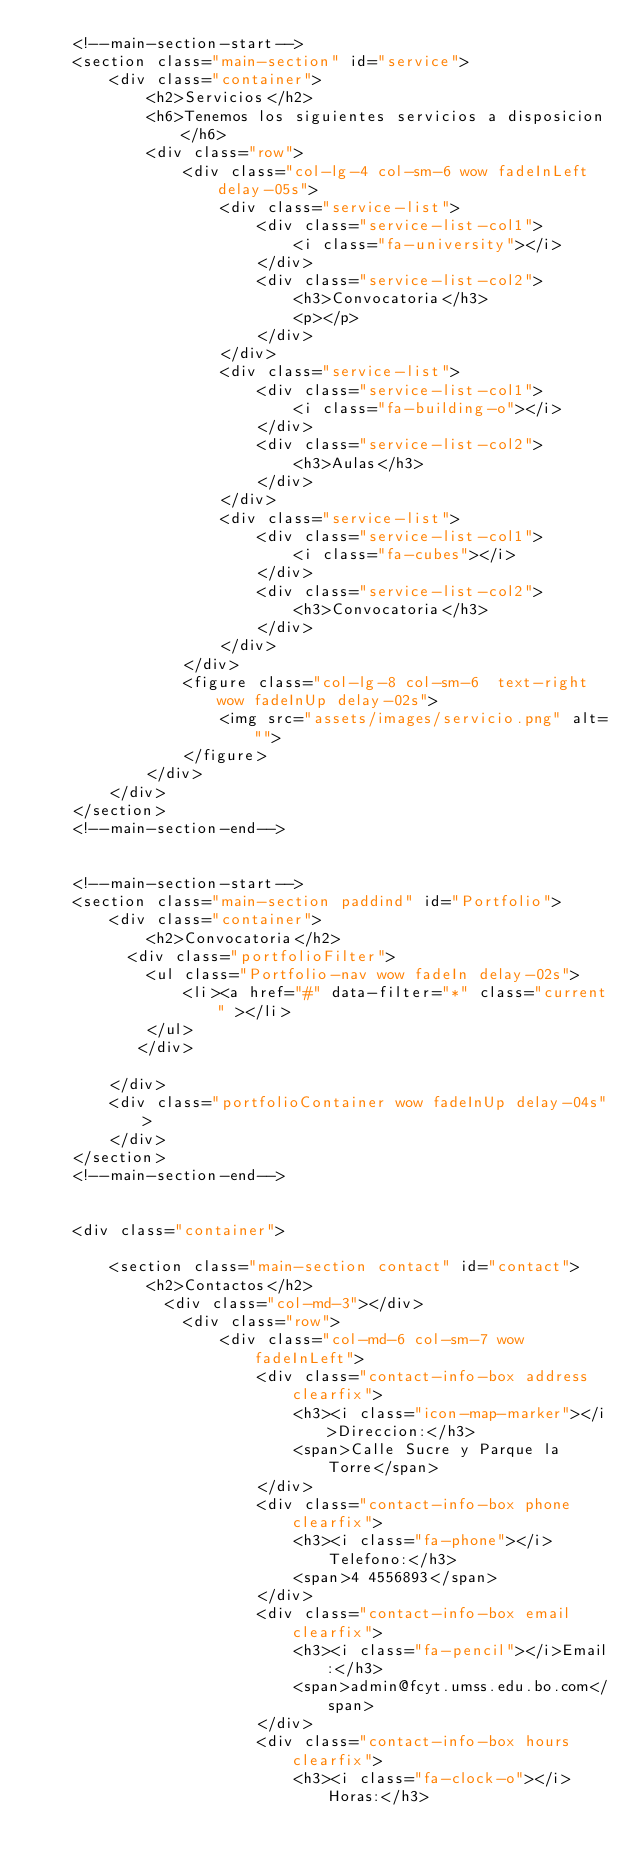<code> <loc_0><loc_0><loc_500><loc_500><_PHP_>    <!--main-section-start-->
    <section class="main-section" id="service">
        <div class="container">
            <h2>Servicios</h2>
            <h6>Tenemos los siguientes servicios a disposicion</h6>
            <div class="row">
                <div class="col-lg-4 col-sm-6 wow fadeInLeft delay-05s">
                    <div class="service-list">
                        <div class="service-list-col1">
                            <i class="fa-university"></i>
                        </div>
                        <div class="service-list-col2">
                            <h3>Convocatoria</h3>
                            <p></p>
                        </div>
                    </div>
                    <div class="service-list">
                        <div class="service-list-col1">
                            <i class="fa-building-o"></i>
                        </div>
                        <div class="service-list-col2">
                            <h3>Aulas</h3>
                        </div>
                    </div>
                    <div class="service-list">
                        <div class="service-list-col1">
                            <i class="fa-cubes"></i>
                        </div>
                        <div class="service-list-col2">
                            <h3>Convocatoria</h3>
                        </div>
                    </div>
                </div>
                <figure class="col-lg-8 col-sm-6  text-right wow fadeInUp delay-02s">
                    <img src="assets/images/servicio.png" alt="">
                </figure>
            </div>
        </div>
    </section>
    <!--main-section-end-->


    <!--main-section-start-->
    <section class="main-section paddind" id="Portfolio">
        <div class="container">
            <h2>Convocatoria</h2>
          <div class="portfolioFilter">
            <ul class="Portfolio-nav wow fadeIn delay-02s">
                <li><a href="#" data-filter="*" class="current" ></li>
            </ul>
           </div>

        </div>
        <div class="portfolioContainer wow fadeInUp delay-04s">
        </div>
    </section>
    <!--main-section-end-->


    <div class="container">

        <section class="main-section contact" id="contact">
            <h2>Contactos</h2>
              <div class="col-md-3"></div>
                <div class="row">
                    <div class="col-md-6 col-sm-7 wow fadeInLeft">
                        <div class="contact-info-box address clearfix">
                            <h3><i class="icon-map-marker"></i>Direccion:</h3>
                            <span>Calle Sucre y Parque la Torre</span>
                        </div>
                        <div class="contact-info-box phone clearfix">
                            <h3><i class="fa-phone"></i>Telefono:</h3>
                            <span>4 4556893</span>
                        </div>
                        <div class="contact-info-box email clearfix">
                            <h3><i class="fa-pencil"></i>Email:</h3>
                            <span>admin@fcyt.umss.edu.bo.com</span>
                        </div>
                        <div class="contact-info-box hours clearfix">
                            <h3><i class="fa-clock-o"></i>Horas:</h3></code> 